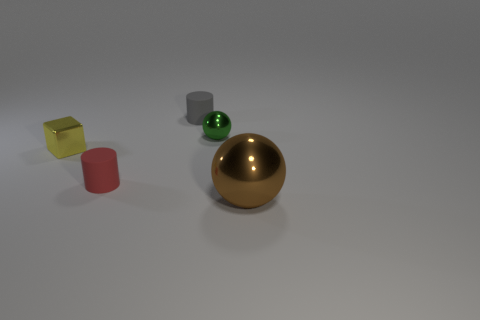What is the shape of the tiny green object?
Make the answer very short. Sphere. There is a large object that is made of the same material as the green sphere; what color is it?
Give a very brief answer. Brown. How many red things are either cubes or metal objects?
Ensure brevity in your answer.  0. Are there more tiny blue blocks than large brown metal spheres?
Make the answer very short. No. What number of things are either tiny yellow things behind the brown metallic sphere or objects that are right of the tiny gray matte cylinder?
Keep it short and to the point. 3. There is a cube that is the same size as the red rubber thing; what color is it?
Provide a short and direct response. Yellow. Is the material of the brown sphere the same as the red cylinder?
Keep it short and to the point. No. The tiny object to the right of the small matte object that is behind the green metallic ball is made of what material?
Keep it short and to the point. Metal. Are there more matte cylinders that are in front of the gray rubber cylinder than large red things?
Your answer should be compact. Yes. How many other objects are there of the same size as the green object?
Ensure brevity in your answer.  3. 